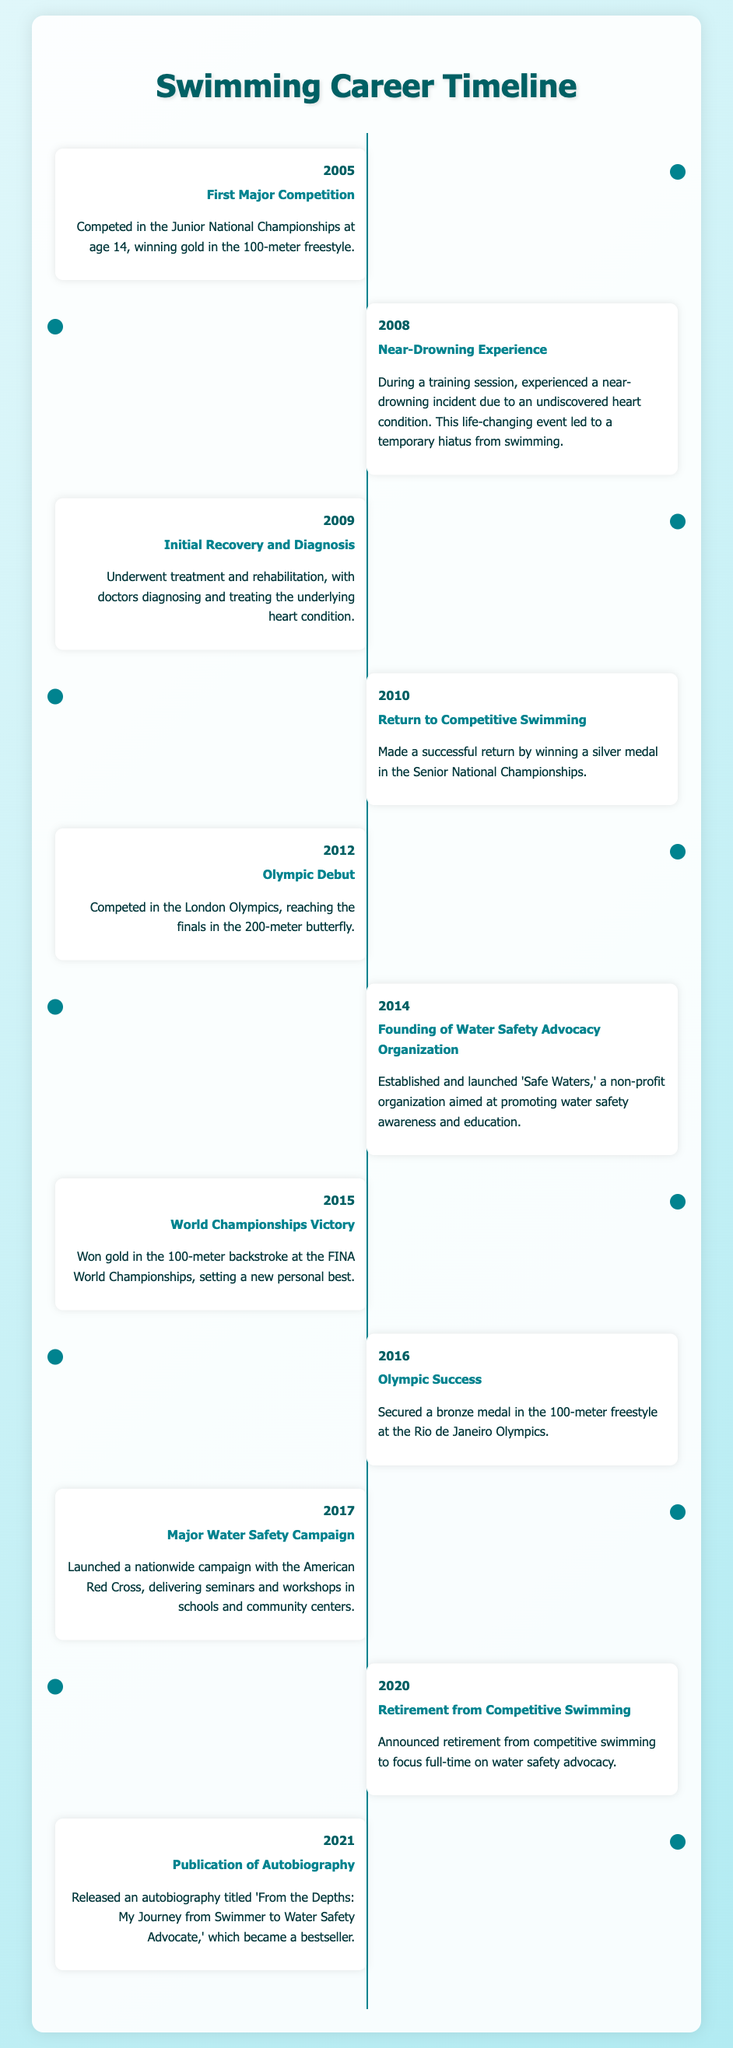What year did you have your first major competition? The document states that the first major competition took place in 2005.
Answer: 2005 What medal did you win at the 2010 Senior National Championships? According to the document, you won a silver medal in this event.
Answer: Silver What significant event occurred in 2008? The document mentions that you experienced a near-drowning incident during a training session in this year.
Answer: Near-drowning incident What organization did you found in 2014? The document states that you established 'Safe Waters' in this year.
Answer: Safe Waters In what year did you secure a bronze medal at the Olympics? The document notes that this achievement took place in 2016.
Answer: 2016 What was the title of your autobiography published in 2021? According to the document, the autobiography is titled 'From the Depths: My Journey from Swimmer to Water Safety Advocate.'
Answer: From the Depths: My Journey from Swimmer to Water Safety Advocate What campaign did you launch in 2017? The document outlines that you launched a nationwide water safety campaign with the American Red Cross in this year.
Answer: Nationwide water safety campaign What milestone did you achieve in 2012? In this year, you competed in the London Olympics and reached the finals in the 200-meter butterfly.
Answer: Olympic debut What specific advocacy efforts began after your retirement in 2020? The document indicates that you focused full-time on water safety advocacy after your retirement.
Answer: Water safety advocacy 